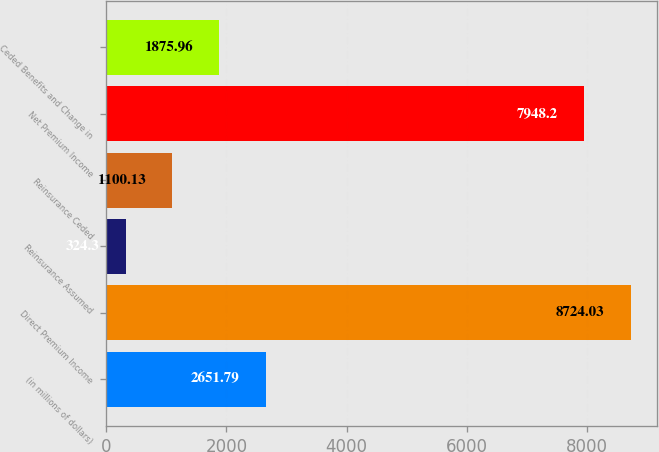<chart> <loc_0><loc_0><loc_500><loc_500><bar_chart><fcel>(in millions of dollars)<fcel>Direct Premium Income<fcel>Reinsurance Assumed<fcel>Reinsurance Ceded<fcel>Net Premium Income<fcel>Ceded Benefits and Change in<nl><fcel>2651.79<fcel>8724.03<fcel>324.3<fcel>1100.13<fcel>7948.2<fcel>1875.96<nl></chart> 